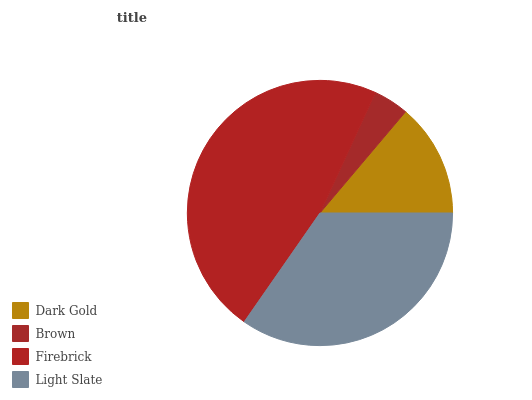Is Brown the minimum?
Answer yes or no. Yes. Is Firebrick the maximum?
Answer yes or no. Yes. Is Firebrick the minimum?
Answer yes or no. No. Is Brown the maximum?
Answer yes or no. No. Is Firebrick greater than Brown?
Answer yes or no. Yes. Is Brown less than Firebrick?
Answer yes or no. Yes. Is Brown greater than Firebrick?
Answer yes or no. No. Is Firebrick less than Brown?
Answer yes or no. No. Is Light Slate the high median?
Answer yes or no. Yes. Is Dark Gold the low median?
Answer yes or no. Yes. Is Firebrick the high median?
Answer yes or no. No. Is Firebrick the low median?
Answer yes or no. No. 